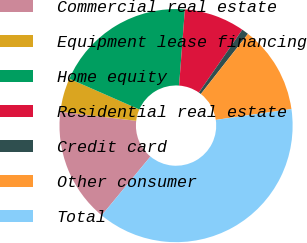Convert chart. <chart><loc_0><loc_0><loc_500><loc_500><pie_chart><fcel>Commercial real estate<fcel>Equipment lease financing<fcel>Home equity<fcel>Residential real estate<fcel>Credit card<fcel>Other consumer<fcel>Total<nl><fcel>15.89%<fcel>4.69%<fcel>19.62%<fcel>8.42%<fcel>0.96%<fcel>12.15%<fcel>38.28%<nl></chart> 